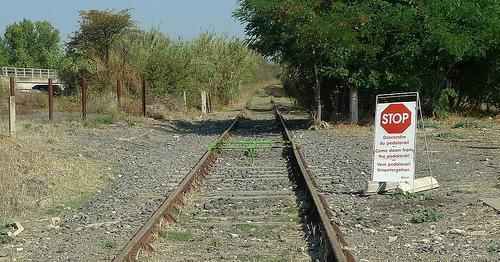How many signs are in this photograph?
Give a very brief answer. 1. How many people are in this photograph?
Give a very brief answer. 0. How many red shapes?
Give a very brief answer. 1. How many rails are on the train track?
Give a very brief answer. 2. 